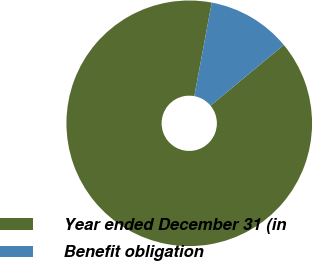<chart> <loc_0><loc_0><loc_500><loc_500><pie_chart><fcel>Year ended December 31 (in<fcel>Benefit obligation<nl><fcel>88.95%<fcel>11.05%<nl></chart> 